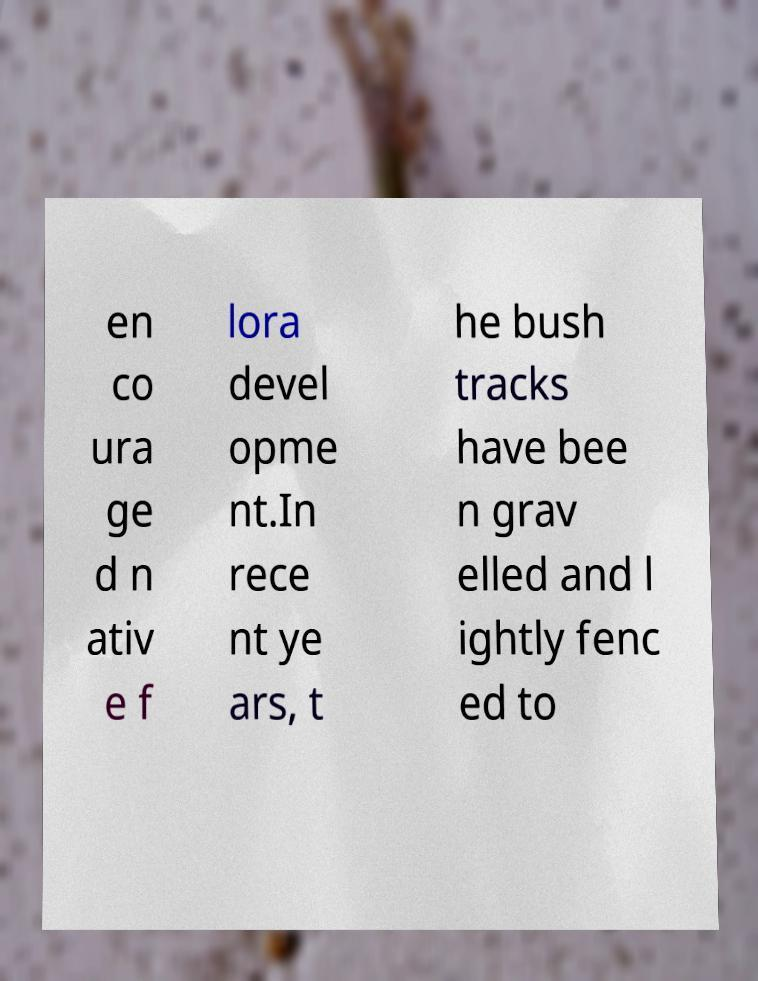Can you read and provide the text displayed in the image?This photo seems to have some interesting text. Can you extract and type it out for me? en co ura ge d n ativ e f lora devel opme nt.In rece nt ye ars, t he bush tracks have bee n grav elled and l ightly fenc ed to 